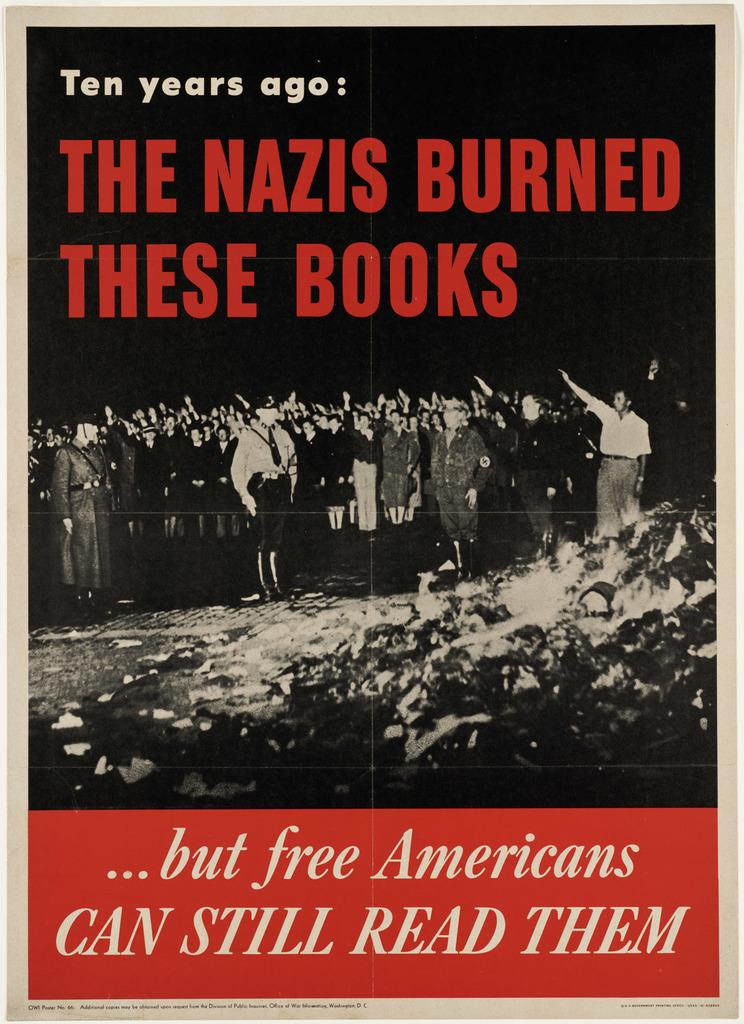<image>
Describe the image concisely. Poster or book displaying red text stating THE NAZIS BURNED THESE BOOKS. 